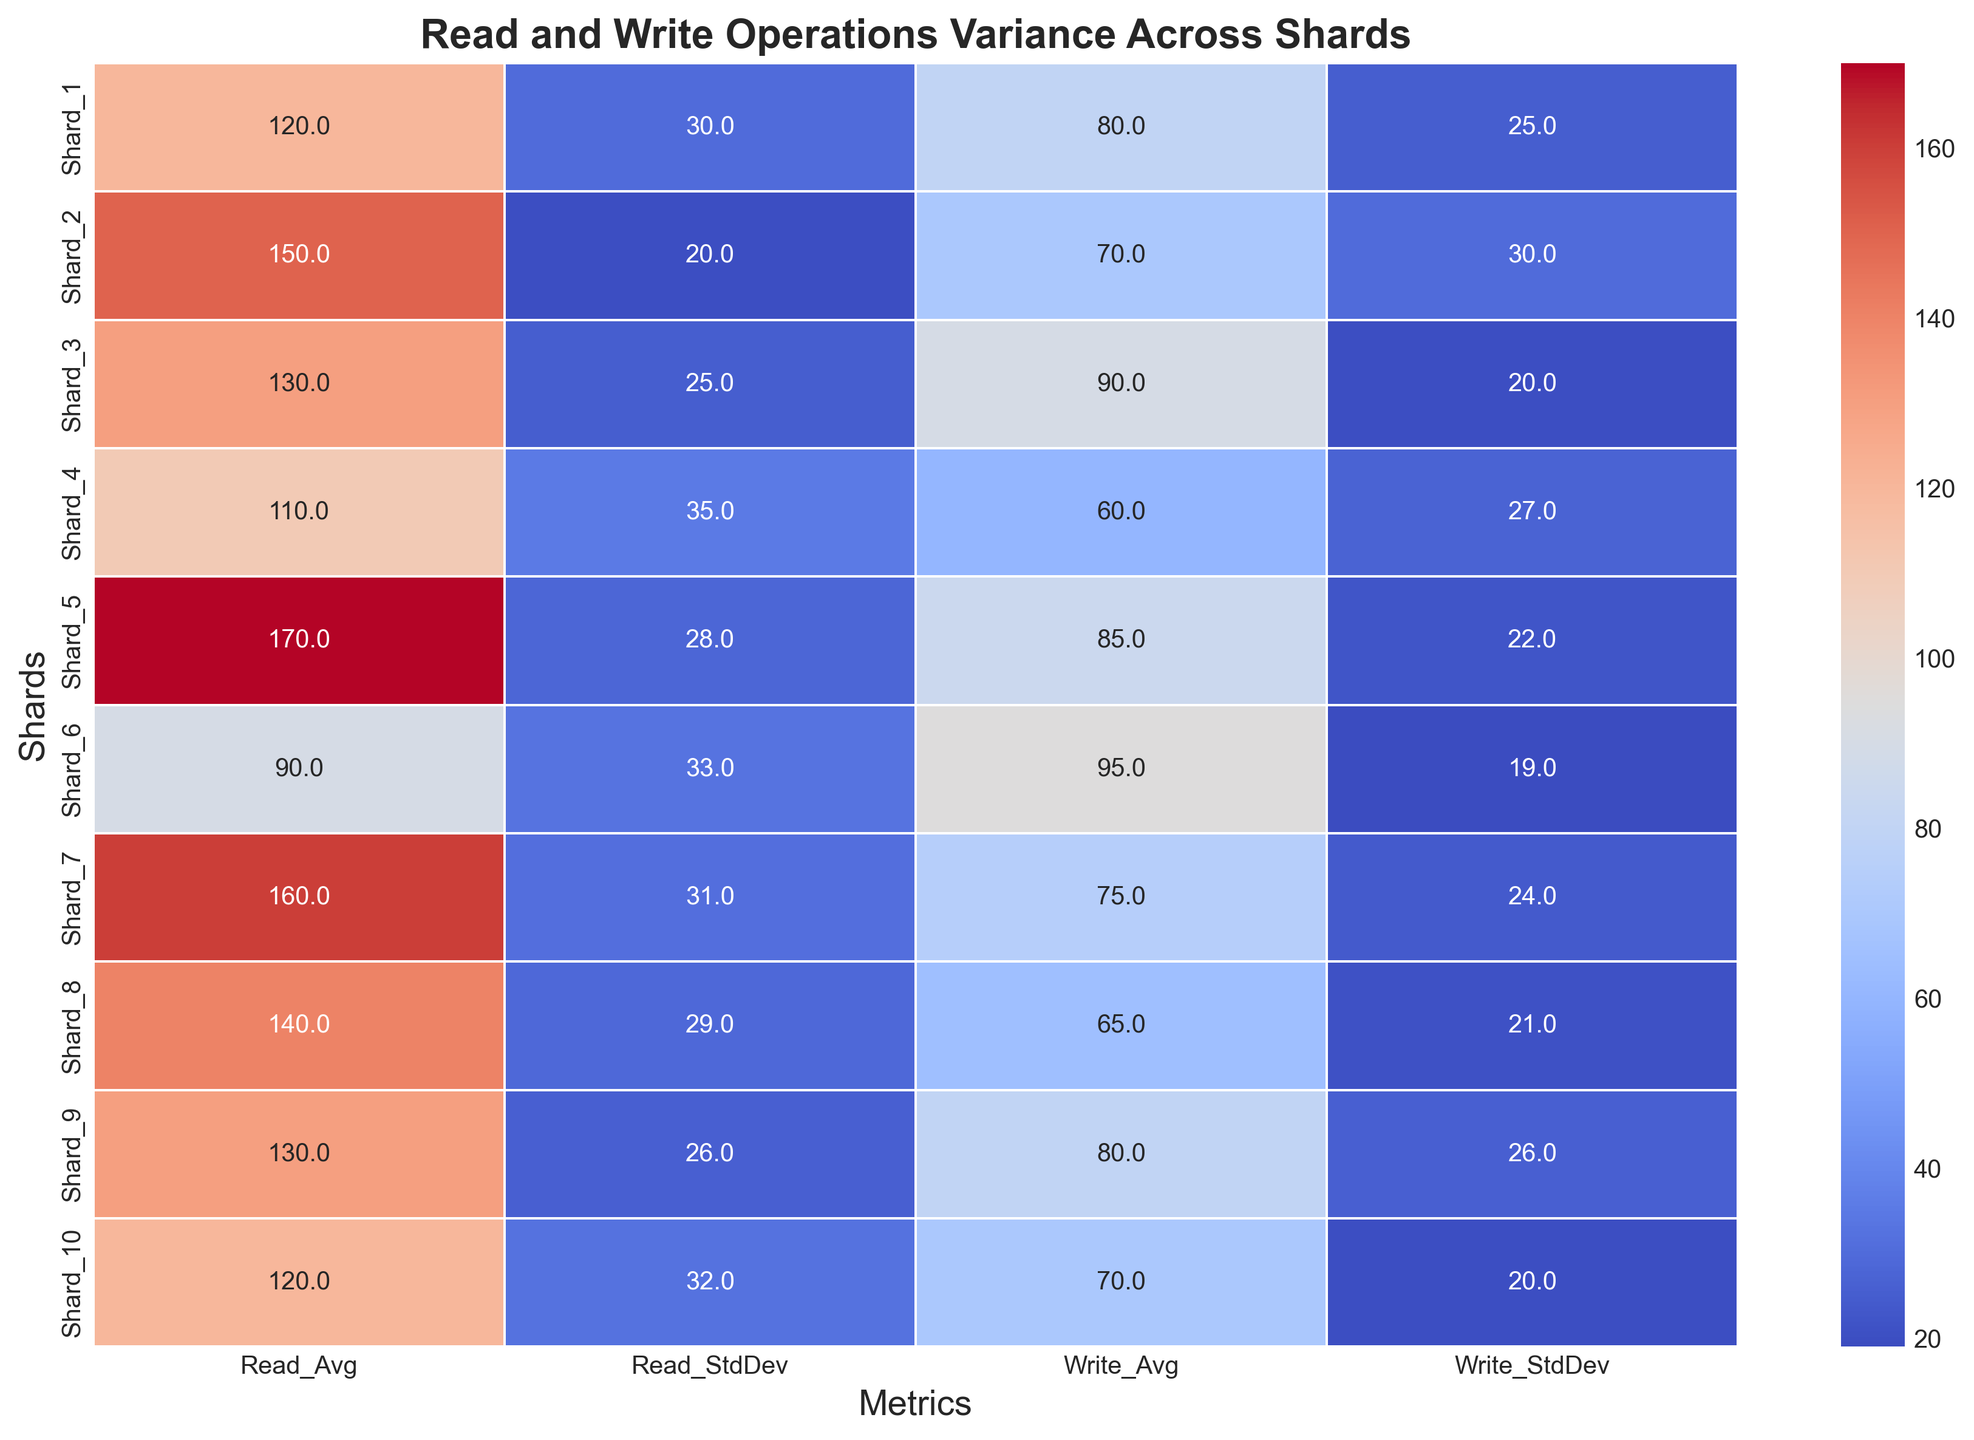Which shard has the highest average write operations? Look at the "Write_Avg" column in the heatmap and identify the highest value. Shard 6 has the highest value at 95.0.
Answer: Shard 6 Which shard exhibits the highest variability in read operations? Look at the "Read_StdDev" values in the heatmap. The shard with the highest standard deviation in read operations is Shard 4 with a value of 35.0.
Answer: Shard 4 What is the difference between the highest and lowest average read operations across shards? Identify the highest "Read_Avg" value, which is in Shard 5 (170), and the lowest "Read_Avg" value, which is in Shard 6 (90). Subtract the lowest from the highest: 170 - 90 = 80.
Answer: 80 How does Shard 7 compare to Shard 3 regarding the average write operations? In the heatmap, Shard 7 has "Write_Avg" of 75, and Shard 3 has "Write_Avg" of 90. Shard 3 has higher average write operations compared to Shard 7.
Answer: Shard 3 has higher average write operations Are there any shards that have both above-average read and write operations (average values > mean of all shards)? First, calculate the mean of "Read_Avg" and "Write_Avg" across all shards. Mean of "Read_Avg" = (120 + 150 + 130 + 110 + 170 + 90 + 160 + 140 + 130 + 120)/10 = 132. Mean of "Write_Avg" = (80 + 70 + 90 + 60 + 85 + 95 + 75 + 65 + 80 + 70)/10 = 77. Shards with both "Read_Avg" > 132 and "Write_Avg" > 77 are Shard 5 and Shard 6.
Answer: Shard 5, Shard 6 Which shard has the least variability in write operations? Look at the "Write_StdDev" values in the heatmap. The shard with the lowest standard deviation in write operations is Shard 6 with a value of 19.0.
Answer: Shard 6 Among the shards with the highest and lowest average read operations, which has a higher variance in write operations? Shard 5 has the highest "Read_Avg" (170) and Shard 6 has the lowest "Read_Avg" (90). Compare their "Write_StdDev" values: Shard 5 (22.0) and Shard 6 (19.0). Shard 5 has a higher variance in write operations.
Answer: Shard 5 What is the sum of the standard deviations of read operations for Shard 2 and Shard 8? Look at "Read_StdDev" values for Shard 2 (20) and Shard 8 (29). Sum them up: 20 + 29 = 49.
Answer: 49 